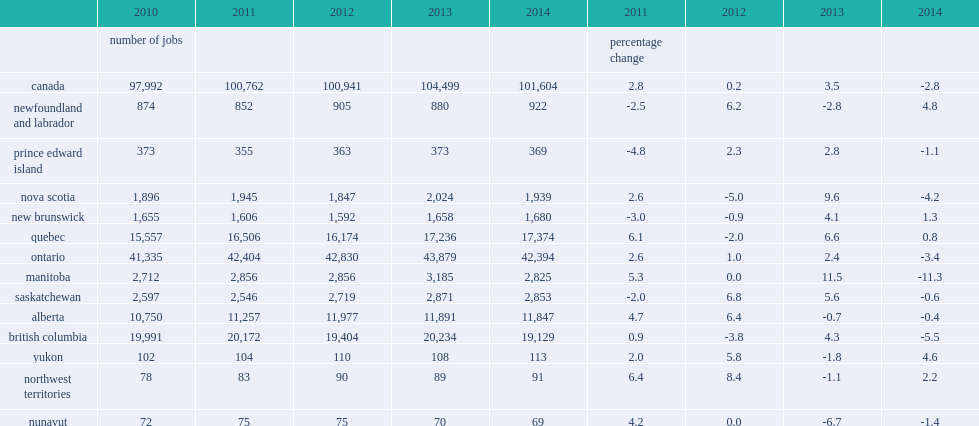What was the percentage of sport jobs declined in canada in 2014? 2.8. Sport jobs declined 2.8% in canada in 2014, what was the percentage of job losses in ontario? -3.4. Sport jobs declined 2.8% in canada in 2014, what was the percentage of job losses in british columbia? -5.5. What was the percentage of sport jobs in newfoundland and labrador rose in 2014? 4.8. What was the percentage of sport jobs in newfoundland and labrador declined in 2013? 2.8. What was the percentage of sport jobs in prince edward island in 2014? 1.1. What was the percentage of sport jobs in prince edward island in 2013? 2.8. What was the percentage of sport jobs in nova scotia in 2014? 4.2. What was the percentage of sport jobs in nova scotia increased in 2013? 9.6. What was the percentage of sport jobs in nova scotia increased in 2014? 1.3. What was the percentage of sport jobs in nova scotia increased in 2013? 4.1. What was the percentage of sport jobs in quebec increased in 2014? 0.8. What was the percentage of sport jobs in quebec increased in 2013? 6.6. What was the percentage of sport jobs in ontario decreased in 2014? 3.4. What was the percentage of sport jobs in ontario increased in 2013? 2.4. What was the percentage of sport jobs in ontario fell in 2014? 11.3. What was the percentage of sport jobs in manitoba increased in 2013? 11.5. What was the percentage of sport jobs in saskatchewan fell in 2014? 0.6. What was the percentage of sport jobs in saskatchewan increased in 2013? 5.6. What was the percentage of sport jobs in saskatchewan declined in 2014? 0.4. What was the percentage of sport jobs in saskatchewan declined in 2013? 0.7. What was the percentage of sport jobs in british columbia declined in 2014? 5.5. What was the percentage of sport jobs in british columbia increased in 2013? 4.3. What was the percentage of sport jobs in british columbia increased in 2014? 4.6. What was the percentage of sport jobs in yukon declined in 2013? 1.8. What was the percentage of sport jobs in northwest territories increased in 2014? 2.2. What was the percentage of sport jobs in northwest territories decreased in 2013? 1.1. What was the percentage of sport jobs in nunavut increased in 2014? 1.4. What was the percentage of sport jobs in nunavut decreased in 2013? 6.7. 